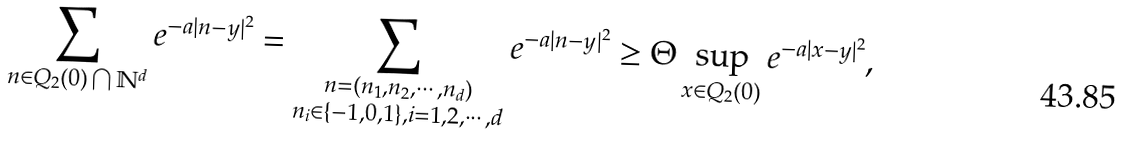Convert formula to latex. <formula><loc_0><loc_0><loc_500><loc_500>\sum _ { n \in Q _ { 2 } ( 0 ) \bigcap \mathbb { N } ^ { d } } e ^ { - a | n - y | ^ { 2 } } & = \sum _ { \substack { n = ( n _ { 1 } , n _ { 2 } , \cdots , n _ { d } ) \\ n _ { i } \in \{ - 1 , 0 , 1 \} , i = 1 , 2 , \cdots , d } } e ^ { - a | n - y | ^ { 2 } } \geq \Theta \sup _ { x \in Q _ { 2 } ( 0 ) } e ^ { - a | x - y | ^ { 2 } } ,</formula> 